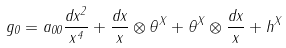<formula> <loc_0><loc_0><loc_500><loc_500>g _ { 0 } = a _ { 0 0 } \frac { d x ^ { 2 } } { x ^ { 4 } } + \frac { d x } { x } \otimes \theta ^ { X } + \theta ^ { X } \otimes \frac { d x } { x } + h ^ { X }</formula> 